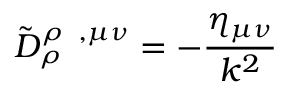Convert formula to latex. <formula><loc_0><loc_0><loc_500><loc_500>\tilde { D } _ { \rho } ^ { \rho \, , \mu \nu } = - \frac { \eta _ { \mu \nu } } { k ^ { 2 } }</formula> 